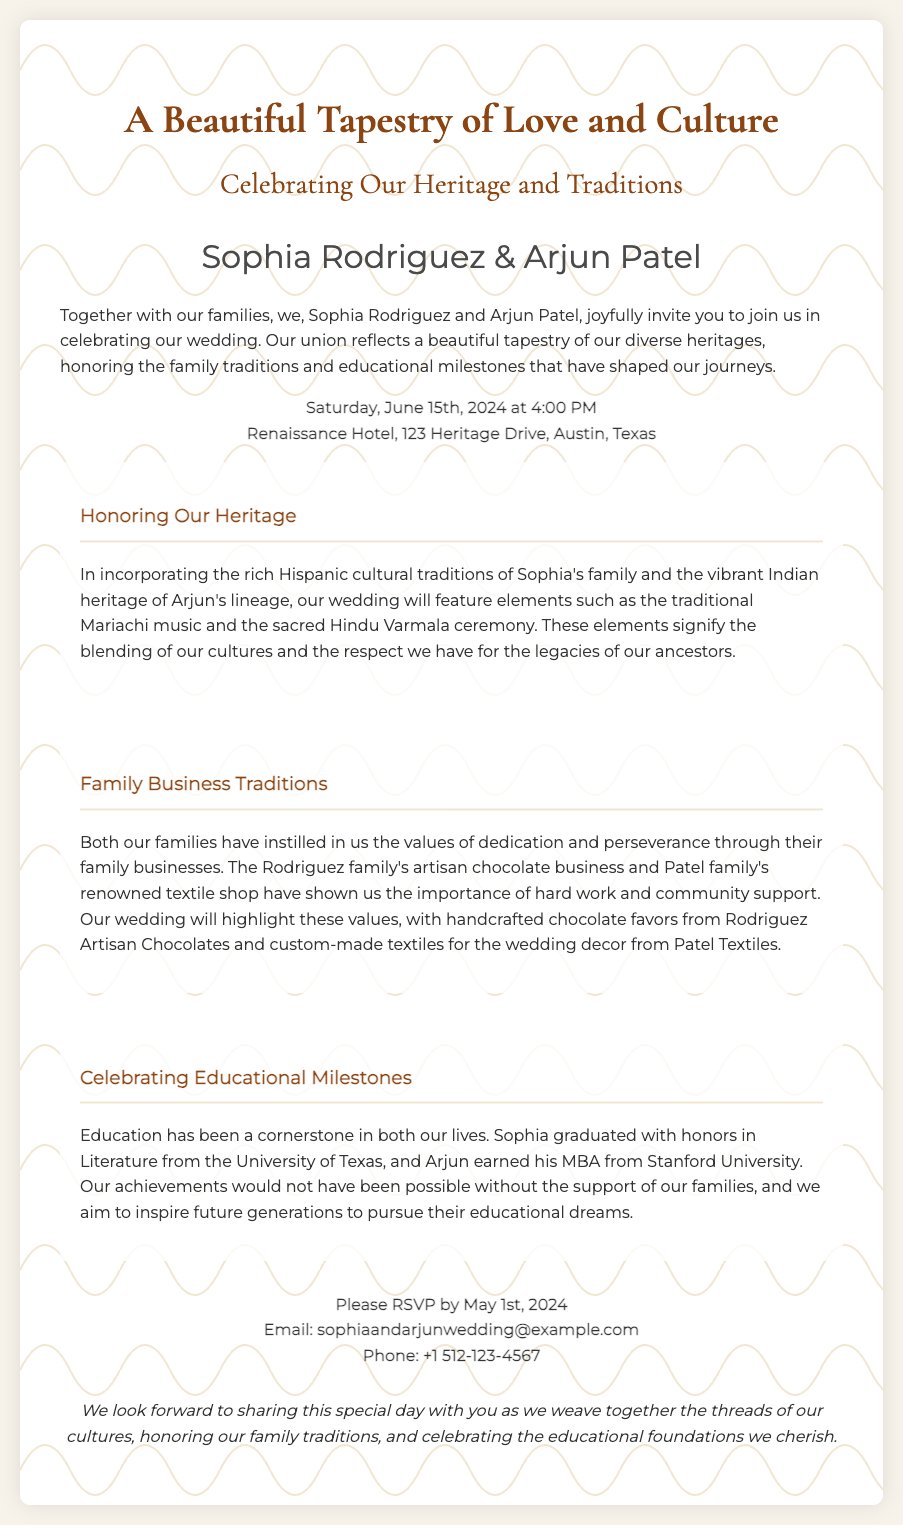What are the names of the couple? The names of the couple are indicated in the invitation section and are Sophia Rodriguez & Arjun Patel.
Answer: Sophia Rodriguez & Arjun Patel What is the date of the wedding? The wedding date is mentioned prominently in the invitation, stated clearly.
Answer: June 15th, 2024 Where will the wedding take place? The location of the wedding is provided in the same section as the date and time, specifying the venue.
Answer: Renaissance Hotel, 123 Heritage Drive, Austin, Texas What types of cultural traditions will be featured? The cultures incorporated include elements from both the Hispanic and Indian traditions, as described in the heritage section.
Answer: Mariachi music and Varmala ceremony What is Sophia's educational achievement? Sophia's educational background is highlighted in the document, noting her degree and institution.
Answer: Literature from the University of Texas What family business is associated with the Rodriguez family? The invitation specifies which family business is linked to the Rodriguez side, reinforcing their heritage.
Answer: Artisan chocolate business What is the RSVP deadline? The invitation clearly provides the RSVP deadline, essential for guest planning.
Answer: May 1st, 2024 What will be included in the wedding favors? The section on family business traditions mentions what will be given to guests as favors.
Answer: Handcrafted chocolate favors How can guests RSVP? The RSVP section outlines how guests can confirm their attendance with the provided contact methods.
Answer: Email: sophiaandarjunwedding@example.com, Phone: +1 512-123-4567 